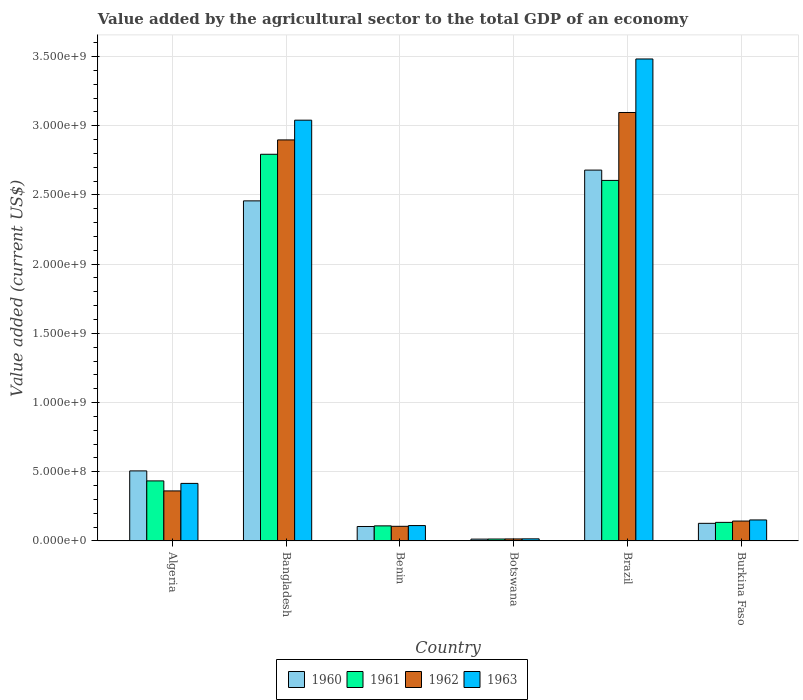Are the number of bars per tick equal to the number of legend labels?
Your answer should be compact. Yes. How many bars are there on the 3rd tick from the left?
Ensure brevity in your answer.  4. What is the label of the 4th group of bars from the left?
Keep it short and to the point. Botswana. In how many cases, is the number of bars for a given country not equal to the number of legend labels?
Offer a terse response. 0. What is the value added by the agricultural sector to the total GDP in 1963 in Brazil?
Keep it short and to the point. 3.48e+09. Across all countries, what is the maximum value added by the agricultural sector to the total GDP in 1963?
Give a very brief answer. 3.48e+09. Across all countries, what is the minimum value added by the agricultural sector to the total GDP in 1960?
Your answer should be compact. 1.31e+07. In which country was the value added by the agricultural sector to the total GDP in 1961 maximum?
Provide a succinct answer. Bangladesh. In which country was the value added by the agricultural sector to the total GDP in 1961 minimum?
Your answer should be very brief. Botswana. What is the total value added by the agricultural sector to the total GDP in 1961 in the graph?
Ensure brevity in your answer.  6.09e+09. What is the difference between the value added by the agricultural sector to the total GDP in 1962 in Botswana and that in Burkina Faso?
Ensure brevity in your answer.  -1.29e+08. What is the difference between the value added by the agricultural sector to the total GDP in 1961 in Burkina Faso and the value added by the agricultural sector to the total GDP in 1963 in Algeria?
Your response must be concise. -2.82e+08. What is the average value added by the agricultural sector to the total GDP in 1962 per country?
Make the answer very short. 1.10e+09. What is the difference between the value added by the agricultural sector to the total GDP of/in 1961 and value added by the agricultural sector to the total GDP of/in 1963 in Brazil?
Your answer should be very brief. -8.77e+08. In how many countries, is the value added by the agricultural sector to the total GDP in 1962 greater than 2800000000 US$?
Keep it short and to the point. 2. What is the ratio of the value added by the agricultural sector to the total GDP in 1961 in Botswana to that in Burkina Faso?
Your answer should be compact. 0.1. Is the value added by the agricultural sector to the total GDP in 1960 in Botswana less than that in Burkina Faso?
Provide a short and direct response. Yes. Is the difference between the value added by the agricultural sector to the total GDP in 1961 in Benin and Brazil greater than the difference between the value added by the agricultural sector to the total GDP in 1963 in Benin and Brazil?
Your response must be concise. Yes. What is the difference between the highest and the second highest value added by the agricultural sector to the total GDP in 1963?
Your answer should be very brief. 2.62e+09. What is the difference between the highest and the lowest value added by the agricultural sector to the total GDP in 1962?
Offer a terse response. 3.08e+09. What is the difference between two consecutive major ticks on the Y-axis?
Offer a terse response. 5.00e+08. How are the legend labels stacked?
Your answer should be compact. Horizontal. What is the title of the graph?
Offer a terse response. Value added by the agricultural sector to the total GDP of an economy. What is the label or title of the X-axis?
Provide a succinct answer. Country. What is the label or title of the Y-axis?
Your answer should be compact. Value added (current US$). What is the Value added (current US$) in 1960 in Algeria?
Keep it short and to the point. 5.06e+08. What is the Value added (current US$) of 1961 in Algeria?
Give a very brief answer. 4.34e+08. What is the Value added (current US$) in 1962 in Algeria?
Offer a terse response. 3.61e+08. What is the Value added (current US$) of 1963 in Algeria?
Provide a succinct answer. 4.16e+08. What is the Value added (current US$) of 1960 in Bangladesh?
Provide a succinct answer. 2.46e+09. What is the Value added (current US$) in 1961 in Bangladesh?
Give a very brief answer. 2.79e+09. What is the Value added (current US$) in 1962 in Bangladesh?
Provide a short and direct response. 2.90e+09. What is the Value added (current US$) of 1963 in Bangladesh?
Give a very brief answer. 3.04e+09. What is the Value added (current US$) of 1960 in Benin?
Provide a short and direct response. 1.04e+08. What is the Value added (current US$) in 1961 in Benin?
Offer a terse response. 1.09e+08. What is the Value added (current US$) in 1962 in Benin?
Your response must be concise. 1.06e+08. What is the Value added (current US$) in 1963 in Benin?
Offer a very short reply. 1.11e+08. What is the Value added (current US$) of 1960 in Botswana?
Give a very brief answer. 1.31e+07. What is the Value added (current US$) in 1961 in Botswana?
Your response must be concise. 1.38e+07. What is the Value added (current US$) of 1962 in Botswana?
Your response must be concise. 1.45e+07. What is the Value added (current US$) of 1963 in Botswana?
Your answer should be compact. 1.51e+07. What is the Value added (current US$) of 1960 in Brazil?
Make the answer very short. 2.68e+09. What is the Value added (current US$) in 1961 in Brazil?
Your response must be concise. 2.60e+09. What is the Value added (current US$) in 1962 in Brazil?
Offer a very short reply. 3.10e+09. What is the Value added (current US$) of 1963 in Brazil?
Ensure brevity in your answer.  3.48e+09. What is the Value added (current US$) of 1960 in Burkina Faso?
Give a very brief answer. 1.27e+08. What is the Value added (current US$) in 1961 in Burkina Faso?
Give a very brief answer. 1.34e+08. What is the Value added (current US$) in 1962 in Burkina Faso?
Your response must be concise. 1.44e+08. What is the Value added (current US$) of 1963 in Burkina Faso?
Your answer should be very brief. 1.52e+08. Across all countries, what is the maximum Value added (current US$) of 1960?
Ensure brevity in your answer.  2.68e+09. Across all countries, what is the maximum Value added (current US$) in 1961?
Make the answer very short. 2.79e+09. Across all countries, what is the maximum Value added (current US$) in 1962?
Your response must be concise. 3.10e+09. Across all countries, what is the maximum Value added (current US$) of 1963?
Your answer should be very brief. 3.48e+09. Across all countries, what is the minimum Value added (current US$) in 1960?
Offer a very short reply. 1.31e+07. Across all countries, what is the minimum Value added (current US$) of 1961?
Ensure brevity in your answer.  1.38e+07. Across all countries, what is the minimum Value added (current US$) of 1962?
Your response must be concise. 1.45e+07. Across all countries, what is the minimum Value added (current US$) in 1963?
Provide a succinct answer. 1.51e+07. What is the total Value added (current US$) of 1960 in the graph?
Offer a very short reply. 5.89e+09. What is the total Value added (current US$) in 1961 in the graph?
Your response must be concise. 6.09e+09. What is the total Value added (current US$) in 1962 in the graph?
Provide a succinct answer. 6.62e+09. What is the total Value added (current US$) in 1963 in the graph?
Offer a terse response. 7.22e+09. What is the difference between the Value added (current US$) of 1960 in Algeria and that in Bangladesh?
Keep it short and to the point. -1.95e+09. What is the difference between the Value added (current US$) in 1961 in Algeria and that in Bangladesh?
Ensure brevity in your answer.  -2.36e+09. What is the difference between the Value added (current US$) in 1962 in Algeria and that in Bangladesh?
Offer a very short reply. -2.54e+09. What is the difference between the Value added (current US$) of 1963 in Algeria and that in Bangladesh?
Your answer should be very brief. -2.62e+09. What is the difference between the Value added (current US$) in 1960 in Algeria and that in Benin?
Provide a succinct answer. 4.02e+08. What is the difference between the Value added (current US$) of 1961 in Algeria and that in Benin?
Keep it short and to the point. 3.25e+08. What is the difference between the Value added (current US$) of 1962 in Algeria and that in Benin?
Keep it short and to the point. 2.56e+08. What is the difference between the Value added (current US$) of 1963 in Algeria and that in Benin?
Make the answer very short. 3.05e+08. What is the difference between the Value added (current US$) in 1960 in Algeria and that in Botswana?
Your answer should be compact. 4.93e+08. What is the difference between the Value added (current US$) of 1961 in Algeria and that in Botswana?
Give a very brief answer. 4.20e+08. What is the difference between the Value added (current US$) of 1962 in Algeria and that in Botswana?
Keep it short and to the point. 3.47e+08. What is the difference between the Value added (current US$) in 1963 in Algeria and that in Botswana?
Provide a succinct answer. 4.01e+08. What is the difference between the Value added (current US$) in 1960 in Algeria and that in Brazil?
Offer a very short reply. -2.17e+09. What is the difference between the Value added (current US$) in 1961 in Algeria and that in Brazil?
Your response must be concise. -2.17e+09. What is the difference between the Value added (current US$) of 1962 in Algeria and that in Brazil?
Give a very brief answer. -2.73e+09. What is the difference between the Value added (current US$) in 1963 in Algeria and that in Brazil?
Offer a very short reply. -3.07e+09. What is the difference between the Value added (current US$) in 1960 in Algeria and that in Burkina Faso?
Your answer should be very brief. 3.79e+08. What is the difference between the Value added (current US$) in 1961 in Algeria and that in Burkina Faso?
Provide a short and direct response. 3.00e+08. What is the difference between the Value added (current US$) in 1962 in Algeria and that in Burkina Faso?
Make the answer very short. 2.18e+08. What is the difference between the Value added (current US$) in 1963 in Algeria and that in Burkina Faso?
Your answer should be very brief. 2.64e+08. What is the difference between the Value added (current US$) in 1960 in Bangladesh and that in Benin?
Your answer should be compact. 2.35e+09. What is the difference between the Value added (current US$) in 1961 in Bangladesh and that in Benin?
Offer a very short reply. 2.68e+09. What is the difference between the Value added (current US$) in 1962 in Bangladesh and that in Benin?
Give a very brief answer. 2.79e+09. What is the difference between the Value added (current US$) in 1963 in Bangladesh and that in Benin?
Offer a very short reply. 2.93e+09. What is the difference between the Value added (current US$) of 1960 in Bangladesh and that in Botswana?
Keep it short and to the point. 2.44e+09. What is the difference between the Value added (current US$) of 1961 in Bangladesh and that in Botswana?
Give a very brief answer. 2.78e+09. What is the difference between the Value added (current US$) in 1962 in Bangladesh and that in Botswana?
Provide a short and direct response. 2.88e+09. What is the difference between the Value added (current US$) in 1963 in Bangladesh and that in Botswana?
Your answer should be very brief. 3.02e+09. What is the difference between the Value added (current US$) of 1960 in Bangladesh and that in Brazil?
Your answer should be very brief. -2.22e+08. What is the difference between the Value added (current US$) in 1961 in Bangladesh and that in Brazil?
Make the answer very short. 1.89e+08. What is the difference between the Value added (current US$) of 1962 in Bangladesh and that in Brazil?
Your answer should be very brief. -1.98e+08. What is the difference between the Value added (current US$) in 1963 in Bangladesh and that in Brazil?
Keep it short and to the point. -4.42e+08. What is the difference between the Value added (current US$) of 1960 in Bangladesh and that in Burkina Faso?
Your answer should be very brief. 2.33e+09. What is the difference between the Value added (current US$) of 1961 in Bangladesh and that in Burkina Faso?
Keep it short and to the point. 2.66e+09. What is the difference between the Value added (current US$) of 1962 in Bangladesh and that in Burkina Faso?
Ensure brevity in your answer.  2.75e+09. What is the difference between the Value added (current US$) in 1963 in Bangladesh and that in Burkina Faso?
Offer a very short reply. 2.89e+09. What is the difference between the Value added (current US$) of 1960 in Benin and that in Botswana?
Offer a terse response. 9.13e+07. What is the difference between the Value added (current US$) in 1961 in Benin and that in Botswana?
Give a very brief answer. 9.51e+07. What is the difference between the Value added (current US$) of 1962 in Benin and that in Botswana?
Give a very brief answer. 9.12e+07. What is the difference between the Value added (current US$) in 1963 in Benin and that in Botswana?
Keep it short and to the point. 9.59e+07. What is the difference between the Value added (current US$) of 1960 in Benin and that in Brazil?
Ensure brevity in your answer.  -2.57e+09. What is the difference between the Value added (current US$) in 1961 in Benin and that in Brazil?
Your answer should be compact. -2.50e+09. What is the difference between the Value added (current US$) of 1962 in Benin and that in Brazil?
Keep it short and to the point. -2.99e+09. What is the difference between the Value added (current US$) in 1963 in Benin and that in Brazil?
Keep it short and to the point. -3.37e+09. What is the difference between the Value added (current US$) in 1960 in Benin and that in Burkina Faso?
Provide a succinct answer. -2.28e+07. What is the difference between the Value added (current US$) in 1961 in Benin and that in Burkina Faso?
Your response must be concise. -2.53e+07. What is the difference between the Value added (current US$) of 1962 in Benin and that in Burkina Faso?
Offer a very short reply. -3.80e+07. What is the difference between the Value added (current US$) of 1963 in Benin and that in Burkina Faso?
Make the answer very short. -4.07e+07. What is the difference between the Value added (current US$) of 1960 in Botswana and that in Brazil?
Ensure brevity in your answer.  -2.67e+09. What is the difference between the Value added (current US$) in 1961 in Botswana and that in Brazil?
Provide a succinct answer. -2.59e+09. What is the difference between the Value added (current US$) of 1962 in Botswana and that in Brazil?
Make the answer very short. -3.08e+09. What is the difference between the Value added (current US$) of 1963 in Botswana and that in Brazil?
Provide a short and direct response. -3.47e+09. What is the difference between the Value added (current US$) of 1960 in Botswana and that in Burkina Faso?
Your answer should be compact. -1.14e+08. What is the difference between the Value added (current US$) in 1961 in Botswana and that in Burkina Faso?
Provide a succinct answer. -1.20e+08. What is the difference between the Value added (current US$) of 1962 in Botswana and that in Burkina Faso?
Make the answer very short. -1.29e+08. What is the difference between the Value added (current US$) in 1963 in Botswana and that in Burkina Faso?
Ensure brevity in your answer.  -1.37e+08. What is the difference between the Value added (current US$) in 1960 in Brazil and that in Burkina Faso?
Your answer should be compact. 2.55e+09. What is the difference between the Value added (current US$) of 1961 in Brazil and that in Burkina Faso?
Keep it short and to the point. 2.47e+09. What is the difference between the Value added (current US$) of 1962 in Brazil and that in Burkina Faso?
Make the answer very short. 2.95e+09. What is the difference between the Value added (current US$) in 1963 in Brazil and that in Burkina Faso?
Ensure brevity in your answer.  3.33e+09. What is the difference between the Value added (current US$) in 1960 in Algeria and the Value added (current US$) in 1961 in Bangladesh?
Make the answer very short. -2.29e+09. What is the difference between the Value added (current US$) of 1960 in Algeria and the Value added (current US$) of 1962 in Bangladesh?
Provide a short and direct response. -2.39e+09. What is the difference between the Value added (current US$) in 1960 in Algeria and the Value added (current US$) in 1963 in Bangladesh?
Your response must be concise. -2.53e+09. What is the difference between the Value added (current US$) of 1961 in Algeria and the Value added (current US$) of 1962 in Bangladesh?
Ensure brevity in your answer.  -2.46e+09. What is the difference between the Value added (current US$) of 1961 in Algeria and the Value added (current US$) of 1963 in Bangladesh?
Give a very brief answer. -2.61e+09. What is the difference between the Value added (current US$) in 1962 in Algeria and the Value added (current US$) in 1963 in Bangladesh?
Make the answer very short. -2.68e+09. What is the difference between the Value added (current US$) of 1960 in Algeria and the Value added (current US$) of 1961 in Benin?
Your answer should be very brief. 3.97e+08. What is the difference between the Value added (current US$) of 1960 in Algeria and the Value added (current US$) of 1962 in Benin?
Make the answer very short. 4.00e+08. What is the difference between the Value added (current US$) of 1960 in Algeria and the Value added (current US$) of 1963 in Benin?
Your answer should be compact. 3.95e+08. What is the difference between the Value added (current US$) of 1961 in Algeria and the Value added (current US$) of 1962 in Benin?
Give a very brief answer. 3.28e+08. What is the difference between the Value added (current US$) of 1961 in Algeria and the Value added (current US$) of 1963 in Benin?
Provide a succinct answer. 3.23e+08. What is the difference between the Value added (current US$) in 1962 in Algeria and the Value added (current US$) in 1963 in Benin?
Your response must be concise. 2.50e+08. What is the difference between the Value added (current US$) in 1960 in Algeria and the Value added (current US$) in 1961 in Botswana?
Make the answer very short. 4.92e+08. What is the difference between the Value added (current US$) of 1960 in Algeria and the Value added (current US$) of 1962 in Botswana?
Your response must be concise. 4.92e+08. What is the difference between the Value added (current US$) in 1960 in Algeria and the Value added (current US$) in 1963 in Botswana?
Your answer should be very brief. 4.91e+08. What is the difference between the Value added (current US$) in 1961 in Algeria and the Value added (current US$) in 1962 in Botswana?
Your response must be concise. 4.19e+08. What is the difference between the Value added (current US$) in 1961 in Algeria and the Value added (current US$) in 1963 in Botswana?
Offer a very short reply. 4.19e+08. What is the difference between the Value added (current US$) in 1962 in Algeria and the Value added (current US$) in 1963 in Botswana?
Make the answer very short. 3.46e+08. What is the difference between the Value added (current US$) in 1960 in Algeria and the Value added (current US$) in 1961 in Brazil?
Provide a succinct answer. -2.10e+09. What is the difference between the Value added (current US$) of 1960 in Algeria and the Value added (current US$) of 1962 in Brazil?
Offer a terse response. -2.59e+09. What is the difference between the Value added (current US$) of 1960 in Algeria and the Value added (current US$) of 1963 in Brazil?
Provide a succinct answer. -2.98e+09. What is the difference between the Value added (current US$) of 1961 in Algeria and the Value added (current US$) of 1962 in Brazil?
Ensure brevity in your answer.  -2.66e+09. What is the difference between the Value added (current US$) in 1961 in Algeria and the Value added (current US$) in 1963 in Brazil?
Your answer should be compact. -3.05e+09. What is the difference between the Value added (current US$) of 1962 in Algeria and the Value added (current US$) of 1963 in Brazil?
Make the answer very short. -3.12e+09. What is the difference between the Value added (current US$) in 1960 in Algeria and the Value added (current US$) in 1961 in Burkina Faso?
Your answer should be very brief. 3.72e+08. What is the difference between the Value added (current US$) of 1960 in Algeria and the Value added (current US$) of 1962 in Burkina Faso?
Offer a terse response. 3.62e+08. What is the difference between the Value added (current US$) in 1960 in Algeria and the Value added (current US$) in 1963 in Burkina Faso?
Provide a short and direct response. 3.54e+08. What is the difference between the Value added (current US$) in 1961 in Algeria and the Value added (current US$) in 1962 in Burkina Faso?
Give a very brief answer. 2.90e+08. What is the difference between the Value added (current US$) in 1961 in Algeria and the Value added (current US$) in 1963 in Burkina Faso?
Give a very brief answer. 2.82e+08. What is the difference between the Value added (current US$) of 1962 in Algeria and the Value added (current US$) of 1963 in Burkina Faso?
Offer a terse response. 2.10e+08. What is the difference between the Value added (current US$) in 1960 in Bangladesh and the Value added (current US$) in 1961 in Benin?
Keep it short and to the point. 2.35e+09. What is the difference between the Value added (current US$) in 1960 in Bangladesh and the Value added (current US$) in 1962 in Benin?
Your answer should be compact. 2.35e+09. What is the difference between the Value added (current US$) of 1960 in Bangladesh and the Value added (current US$) of 1963 in Benin?
Ensure brevity in your answer.  2.35e+09. What is the difference between the Value added (current US$) of 1961 in Bangladesh and the Value added (current US$) of 1962 in Benin?
Provide a succinct answer. 2.69e+09. What is the difference between the Value added (current US$) in 1961 in Bangladesh and the Value added (current US$) in 1963 in Benin?
Keep it short and to the point. 2.68e+09. What is the difference between the Value added (current US$) in 1962 in Bangladesh and the Value added (current US$) in 1963 in Benin?
Offer a terse response. 2.79e+09. What is the difference between the Value added (current US$) in 1960 in Bangladesh and the Value added (current US$) in 1961 in Botswana?
Provide a succinct answer. 2.44e+09. What is the difference between the Value added (current US$) in 1960 in Bangladesh and the Value added (current US$) in 1962 in Botswana?
Your response must be concise. 2.44e+09. What is the difference between the Value added (current US$) of 1960 in Bangladesh and the Value added (current US$) of 1963 in Botswana?
Your answer should be very brief. 2.44e+09. What is the difference between the Value added (current US$) in 1961 in Bangladesh and the Value added (current US$) in 1962 in Botswana?
Keep it short and to the point. 2.78e+09. What is the difference between the Value added (current US$) in 1961 in Bangladesh and the Value added (current US$) in 1963 in Botswana?
Offer a terse response. 2.78e+09. What is the difference between the Value added (current US$) of 1962 in Bangladesh and the Value added (current US$) of 1963 in Botswana?
Offer a very short reply. 2.88e+09. What is the difference between the Value added (current US$) of 1960 in Bangladesh and the Value added (current US$) of 1961 in Brazil?
Provide a short and direct response. -1.48e+08. What is the difference between the Value added (current US$) in 1960 in Bangladesh and the Value added (current US$) in 1962 in Brazil?
Your response must be concise. -6.39e+08. What is the difference between the Value added (current US$) in 1960 in Bangladesh and the Value added (current US$) in 1963 in Brazil?
Offer a very short reply. -1.03e+09. What is the difference between the Value added (current US$) of 1961 in Bangladesh and the Value added (current US$) of 1962 in Brazil?
Your answer should be very brief. -3.02e+08. What is the difference between the Value added (current US$) in 1961 in Bangladesh and the Value added (current US$) in 1963 in Brazil?
Offer a very short reply. -6.89e+08. What is the difference between the Value added (current US$) of 1962 in Bangladesh and the Value added (current US$) of 1963 in Brazil?
Ensure brevity in your answer.  -5.85e+08. What is the difference between the Value added (current US$) of 1960 in Bangladesh and the Value added (current US$) of 1961 in Burkina Faso?
Make the answer very short. 2.32e+09. What is the difference between the Value added (current US$) of 1960 in Bangladesh and the Value added (current US$) of 1962 in Burkina Faso?
Keep it short and to the point. 2.31e+09. What is the difference between the Value added (current US$) of 1960 in Bangladesh and the Value added (current US$) of 1963 in Burkina Faso?
Provide a short and direct response. 2.31e+09. What is the difference between the Value added (current US$) in 1961 in Bangladesh and the Value added (current US$) in 1962 in Burkina Faso?
Keep it short and to the point. 2.65e+09. What is the difference between the Value added (current US$) in 1961 in Bangladesh and the Value added (current US$) in 1963 in Burkina Faso?
Provide a succinct answer. 2.64e+09. What is the difference between the Value added (current US$) of 1962 in Bangladesh and the Value added (current US$) of 1963 in Burkina Faso?
Provide a short and direct response. 2.75e+09. What is the difference between the Value added (current US$) in 1960 in Benin and the Value added (current US$) in 1961 in Botswana?
Keep it short and to the point. 9.06e+07. What is the difference between the Value added (current US$) of 1960 in Benin and the Value added (current US$) of 1962 in Botswana?
Your answer should be very brief. 8.99e+07. What is the difference between the Value added (current US$) in 1960 in Benin and the Value added (current US$) in 1963 in Botswana?
Offer a very short reply. 8.93e+07. What is the difference between the Value added (current US$) in 1961 in Benin and the Value added (current US$) in 1962 in Botswana?
Your answer should be compact. 9.44e+07. What is the difference between the Value added (current US$) in 1961 in Benin and the Value added (current US$) in 1963 in Botswana?
Offer a very short reply. 9.37e+07. What is the difference between the Value added (current US$) in 1962 in Benin and the Value added (current US$) in 1963 in Botswana?
Your response must be concise. 9.06e+07. What is the difference between the Value added (current US$) of 1960 in Benin and the Value added (current US$) of 1961 in Brazil?
Keep it short and to the point. -2.50e+09. What is the difference between the Value added (current US$) of 1960 in Benin and the Value added (current US$) of 1962 in Brazil?
Make the answer very short. -2.99e+09. What is the difference between the Value added (current US$) in 1960 in Benin and the Value added (current US$) in 1963 in Brazil?
Ensure brevity in your answer.  -3.38e+09. What is the difference between the Value added (current US$) in 1961 in Benin and the Value added (current US$) in 1962 in Brazil?
Your answer should be very brief. -2.99e+09. What is the difference between the Value added (current US$) in 1961 in Benin and the Value added (current US$) in 1963 in Brazil?
Give a very brief answer. -3.37e+09. What is the difference between the Value added (current US$) of 1962 in Benin and the Value added (current US$) of 1963 in Brazil?
Ensure brevity in your answer.  -3.38e+09. What is the difference between the Value added (current US$) of 1960 in Benin and the Value added (current US$) of 1961 in Burkina Faso?
Ensure brevity in your answer.  -2.98e+07. What is the difference between the Value added (current US$) in 1960 in Benin and the Value added (current US$) in 1962 in Burkina Faso?
Provide a short and direct response. -3.93e+07. What is the difference between the Value added (current US$) in 1960 in Benin and the Value added (current US$) in 1963 in Burkina Faso?
Your answer should be compact. -4.73e+07. What is the difference between the Value added (current US$) in 1961 in Benin and the Value added (current US$) in 1962 in Burkina Faso?
Offer a terse response. -3.48e+07. What is the difference between the Value added (current US$) in 1961 in Benin and the Value added (current US$) in 1963 in Burkina Faso?
Keep it short and to the point. -4.28e+07. What is the difference between the Value added (current US$) in 1962 in Benin and the Value added (current US$) in 1963 in Burkina Faso?
Your response must be concise. -4.60e+07. What is the difference between the Value added (current US$) of 1960 in Botswana and the Value added (current US$) of 1961 in Brazil?
Your answer should be very brief. -2.59e+09. What is the difference between the Value added (current US$) in 1960 in Botswana and the Value added (current US$) in 1962 in Brazil?
Offer a very short reply. -3.08e+09. What is the difference between the Value added (current US$) in 1960 in Botswana and the Value added (current US$) in 1963 in Brazil?
Make the answer very short. -3.47e+09. What is the difference between the Value added (current US$) of 1961 in Botswana and the Value added (current US$) of 1962 in Brazil?
Provide a succinct answer. -3.08e+09. What is the difference between the Value added (current US$) in 1961 in Botswana and the Value added (current US$) in 1963 in Brazil?
Your response must be concise. -3.47e+09. What is the difference between the Value added (current US$) of 1962 in Botswana and the Value added (current US$) of 1963 in Brazil?
Ensure brevity in your answer.  -3.47e+09. What is the difference between the Value added (current US$) of 1960 in Botswana and the Value added (current US$) of 1961 in Burkina Faso?
Provide a succinct answer. -1.21e+08. What is the difference between the Value added (current US$) of 1960 in Botswana and the Value added (current US$) of 1962 in Burkina Faso?
Give a very brief answer. -1.31e+08. What is the difference between the Value added (current US$) in 1960 in Botswana and the Value added (current US$) in 1963 in Burkina Faso?
Provide a short and direct response. -1.39e+08. What is the difference between the Value added (current US$) in 1961 in Botswana and the Value added (current US$) in 1962 in Burkina Faso?
Your answer should be very brief. -1.30e+08. What is the difference between the Value added (current US$) of 1961 in Botswana and the Value added (current US$) of 1963 in Burkina Faso?
Your answer should be compact. -1.38e+08. What is the difference between the Value added (current US$) in 1962 in Botswana and the Value added (current US$) in 1963 in Burkina Faso?
Give a very brief answer. -1.37e+08. What is the difference between the Value added (current US$) of 1960 in Brazil and the Value added (current US$) of 1961 in Burkina Faso?
Your answer should be compact. 2.55e+09. What is the difference between the Value added (current US$) of 1960 in Brazil and the Value added (current US$) of 1962 in Burkina Faso?
Your answer should be compact. 2.54e+09. What is the difference between the Value added (current US$) of 1960 in Brazil and the Value added (current US$) of 1963 in Burkina Faso?
Your answer should be very brief. 2.53e+09. What is the difference between the Value added (current US$) in 1961 in Brazil and the Value added (current US$) in 1962 in Burkina Faso?
Keep it short and to the point. 2.46e+09. What is the difference between the Value added (current US$) in 1961 in Brazil and the Value added (current US$) in 1963 in Burkina Faso?
Your answer should be very brief. 2.45e+09. What is the difference between the Value added (current US$) of 1962 in Brazil and the Value added (current US$) of 1963 in Burkina Faso?
Keep it short and to the point. 2.94e+09. What is the average Value added (current US$) of 1960 per country?
Your response must be concise. 9.81e+08. What is the average Value added (current US$) of 1961 per country?
Keep it short and to the point. 1.01e+09. What is the average Value added (current US$) in 1962 per country?
Offer a terse response. 1.10e+09. What is the average Value added (current US$) in 1963 per country?
Make the answer very short. 1.20e+09. What is the difference between the Value added (current US$) in 1960 and Value added (current US$) in 1961 in Algeria?
Ensure brevity in your answer.  7.23e+07. What is the difference between the Value added (current US$) in 1960 and Value added (current US$) in 1962 in Algeria?
Your answer should be very brief. 1.45e+08. What is the difference between the Value added (current US$) in 1960 and Value added (current US$) in 1963 in Algeria?
Keep it short and to the point. 9.04e+07. What is the difference between the Value added (current US$) in 1961 and Value added (current US$) in 1962 in Algeria?
Make the answer very short. 7.23e+07. What is the difference between the Value added (current US$) of 1961 and Value added (current US$) of 1963 in Algeria?
Your answer should be compact. 1.81e+07. What is the difference between the Value added (current US$) in 1962 and Value added (current US$) in 1963 in Algeria?
Offer a terse response. -5.42e+07. What is the difference between the Value added (current US$) of 1960 and Value added (current US$) of 1961 in Bangladesh?
Keep it short and to the point. -3.37e+08. What is the difference between the Value added (current US$) of 1960 and Value added (current US$) of 1962 in Bangladesh?
Provide a short and direct response. -4.40e+08. What is the difference between the Value added (current US$) in 1960 and Value added (current US$) in 1963 in Bangladesh?
Your answer should be very brief. -5.83e+08. What is the difference between the Value added (current US$) in 1961 and Value added (current US$) in 1962 in Bangladesh?
Offer a terse response. -1.04e+08. What is the difference between the Value added (current US$) in 1961 and Value added (current US$) in 1963 in Bangladesh?
Offer a terse response. -2.46e+08. What is the difference between the Value added (current US$) of 1962 and Value added (current US$) of 1963 in Bangladesh?
Give a very brief answer. -1.43e+08. What is the difference between the Value added (current US$) in 1960 and Value added (current US$) in 1961 in Benin?
Your answer should be very brief. -4.46e+06. What is the difference between the Value added (current US$) of 1960 and Value added (current US$) of 1962 in Benin?
Give a very brief answer. -1.30e+06. What is the difference between the Value added (current US$) in 1960 and Value added (current US$) in 1963 in Benin?
Your response must be concise. -6.61e+06. What is the difference between the Value added (current US$) in 1961 and Value added (current US$) in 1962 in Benin?
Make the answer very short. 3.16e+06. What is the difference between the Value added (current US$) of 1961 and Value added (current US$) of 1963 in Benin?
Provide a succinct answer. -2.15e+06. What is the difference between the Value added (current US$) in 1962 and Value added (current US$) in 1963 in Benin?
Make the answer very short. -5.30e+06. What is the difference between the Value added (current US$) in 1960 and Value added (current US$) in 1961 in Botswana?
Give a very brief answer. -6.50e+05. What is the difference between the Value added (current US$) in 1960 and Value added (current US$) in 1962 in Botswana?
Give a very brief answer. -1.35e+06. What is the difference between the Value added (current US$) in 1960 and Value added (current US$) in 1963 in Botswana?
Keep it short and to the point. -1.99e+06. What is the difference between the Value added (current US$) of 1961 and Value added (current US$) of 1962 in Botswana?
Keep it short and to the point. -7.04e+05. What is the difference between the Value added (current US$) of 1961 and Value added (current US$) of 1963 in Botswana?
Provide a succinct answer. -1.34e+06. What is the difference between the Value added (current US$) of 1962 and Value added (current US$) of 1963 in Botswana?
Give a very brief answer. -6.34e+05. What is the difference between the Value added (current US$) in 1960 and Value added (current US$) in 1961 in Brazil?
Your response must be concise. 7.45e+07. What is the difference between the Value added (current US$) in 1960 and Value added (current US$) in 1962 in Brazil?
Your response must be concise. -4.16e+08. What is the difference between the Value added (current US$) of 1960 and Value added (current US$) of 1963 in Brazil?
Ensure brevity in your answer.  -8.03e+08. What is the difference between the Value added (current US$) in 1961 and Value added (current US$) in 1962 in Brazil?
Provide a succinct answer. -4.91e+08. What is the difference between the Value added (current US$) of 1961 and Value added (current US$) of 1963 in Brazil?
Your answer should be compact. -8.77e+08. What is the difference between the Value added (current US$) in 1962 and Value added (current US$) in 1963 in Brazil?
Your response must be concise. -3.87e+08. What is the difference between the Value added (current US$) in 1960 and Value added (current US$) in 1961 in Burkina Faso?
Your response must be concise. -7.00e+06. What is the difference between the Value added (current US$) of 1960 and Value added (current US$) of 1962 in Burkina Faso?
Your answer should be compact. -1.65e+07. What is the difference between the Value added (current US$) in 1960 and Value added (current US$) in 1963 in Burkina Faso?
Your answer should be compact. -2.45e+07. What is the difference between the Value added (current US$) in 1961 and Value added (current US$) in 1962 in Burkina Faso?
Offer a terse response. -9.53e+06. What is the difference between the Value added (current US$) in 1961 and Value added (current US$) in 1963 in Burkina Faso?
Your answer should be very brief. -1.75e+07. What is the difference between the Value added (current US$) of 1962 and Value added (current US$) of 1963 in Burkina Faso?
Keep it short and to the point. -7.98e+06. What is the ratio of the Value added (current US$) of 1960 in Algeria to that in Bangladesh?
Your answer should be compact. 0.21. What is the ratio of the Value added (current US$) in 1961 in Algeria to that in Bangladesh?
Your answer should be very brief. 0.16. What is the ratio of the Value added (current US$) in 1962 in Algeria to that in Bangladesh?
Give a very brief answer. 0.12. What is the ratio of the Value added (current US$) in 1963 in Algeria to that in Bangladesh?
Your response must be concise. 0.14. What is the ratio of the Value added (current US$) of 1960 in Algeria to that in Benin?
Keep it short and to the point. 4.85. What is the ratio of the Value added (current US$) of 1961 in Algeria to that in Benin?
Offer a terse response. 3.98. What is the ratio of the Value added (current US$) of 1962 in Algeria to that in Benin?
Ensure brevity in your answer.  3.42. What is the ratio of the Value added (current US$) of 1963 in Algeria to that in Benin?
Ensure brevity in your answer.  3.74. What is the ratio of the Value added (current US$) in 1960 in Algeria to that in Botswana?
Offer a very short reply. 38.5. What is the ratio of the Value added (current US$) of 1961 in Algeria to that in Botswana?
Make the answer very short. 31.45. What is the ratio of the Value added (current US$) of 1962 in Algeria to that in Botswana?
Your answer should be compact. 24.93. What is the ratio of the Value added (current US$) in 1963 in Algeria to that in Botswana?
Provide a succinct answer. 27.47. What is the ratio of the Value added (current US$) of 1960 in Algeria to that in Brazil?
Make the answer very short. 0.19. What is the ratio of the Value added (current US$) in 1961 in Algeria to that in Brazil?
Make the answer very short. 0.17. What is the ratio of the Value added (current US$) in 1962 in Algeria to that in Brazil?
Your answer should be compact. 0.12. What is the ratio of the Value added (current US$) in 1963 in Algeria to that in Brazil?
Your answer should be compact. 0.12. What is the ratio of the Value added (current US$) in 1960 in Algeria to that in Burkina Faso?
Offer a very short reply. 3.98. What is the ratio of the Value added (current US$) of 1961 in Algeria to that in Burkina Faso?
Ensure brevity in your answer.  3.23. What is the ratio of the Value added (current US$) in 1962 in Algeria to that in Burkina Faso?
Offer a terse response. 2.52. What is the ratio of the Value added (current US$) of 1963 in Algeria to that in Burkina Faso?
Ensure brevity in your answer.  2.74. What is the ratio of the Value added (current US$) of 1960 in Bangladesh to that in Benin?
Give a very brief answer. 23.53. What is the ratio of the Value added (current US$) in 1961 in Bangladesh to that in Benin?
Offer a very short reply. 25.66. What is the ratio of the Value added (current US$) of 1962 in Bangladesh to that in Benin?
Your answer should be compact. 27.41. What is the ratio of the Value added (current US$) in 1963 in Bangladesh to that in Benin?
Provide a succinct answer. 27.38. What is the ratio of the Value added (current US$) in 1960 in Bangladesh to that in Botswana?
Offer a very short reply. 186.92. What is the ratio of the Value added (current US$) in 1961 in Bangladesh to that in Botswana?
Ensure brevity in your answer.  202.51. What is the ratio of the Value added (current US$) in 1962 in Bangladesh to that in Botswana?
Give a very brief answer. 199.83. What is the ratio of the Value added (current US$) of 1963 in Bangladesh to that in Botswana?
Offer a terse response. 200.88. What is the ratio of the Value added (current US$) in 1960 in Bangladesh to that in Brazil?
Make the answer very short. 0.92. What is the ratio of the Value added (current US$) of 1961 in Bangladesh to that in Brazil?
Ensure brevity in your answer.  1.07. What is the ratio of the Value added (current US$) of 1962 in Bangladesh to that in Brazil?
Keep it short and to the point. 0.94. What is the ratio of the Value added (current US$) of 1963 in Bangladesh to that in Brazil?
Your answer should be very brief. 0.87. What is the ratio of the Value added (current US$) of 1960 in Bangladesh to that in Burkina Faso?
Your answer should be compact. 19.32. What is the ratio of the Value added (current US$) of 1961 in Bangladesh to that in Burkina Faso?
Provide a short and direct response. 20.82. What is the ratio of the Value added (current US$) in 1962 in Bangladesh to that in Burkina Faso?
Your answer should be very brief. 20.16. What is the ratio of the Value added (current US$) of 1963 in Bangladesh to that in Burkina Faso?
Provide a succinct answer. 20.04. What is the ratio of the Value added (current US$) of 1960 in Benin to that in Botswana?
Your response must be concise. 7.94. What is the ratio of the Value added (current US$) of 1961 in Benin to that in Botswana?
Ensure brevity in your answer.  7.89. What is the ratio of the Value added (current US$) of 1962 in Benin to that in Botswana?
Your response must be concise. 7.29. What is the ratio of the Value added (current US$) of 1963 in Benin to that in Botswana?
Offer a terse response. 7.34. What is the ratio of the Value added (current US$) of 1960 in Benin to that in Brazil?
Your answer should be very brief. 0.04. What is the ratio of the Value added (current US$) of 1961 in Benin to that in Brazil?
Ensure brevity in your answer.  0.04. What is the ratio of the Value added (current US$) in 1962 in Benin to that in Brazil?
Make the answer very short. 0.03. What is the ratio of the Value added (current US$) of 1963 in Benin to that in Brazil?
Keep it short and to the point. 0.03. What is the ratio of the Value added (current US$) of 1960 in Benin to that in Burkina Faso?
Your answer should be compact. 0.82. What is the ratio of the Value added (current US$) of 1961 in Benin to that in Burkina Faso?
Keep it short and to the point. 0.81. What is the ratio of the Value added (current US$) of 1962 in Benin to that in Burkina Faso?
Give a very brief answer. 0.74. What is the ratio of the Value added (current US$) in 1963 in Benin to that in Burkina Faso?
Make the answer very short. 0.73. What is the ratio of the Value added (current US$) in 1960 in Botswana to that in Brazil?
Give a very brief answer. 0. What is the ratio of the Value added (current US$) of 1961 in Botswana to that in Brazil?
Offer a very short reply. 0.01. What is the ratio of the Value added (current US$) in 1962 in Botswana to that in Brazil?
Ensure brevity in your answer.  0. What is the ratio of the Value added (current US$) of 1963 in Botswana to that in Brazil?
Ensure brevity in your answer.  0. What is the ratio of the Value added (current US$) of 1960 in Botswana to that in Burkina Faso?
Your answer should be compact. 0.1. What is the ratio of the Value added (current US$) in 1961 in Botswana to that in Burkina Faso?
Your answer should be compact. 0.1. What is the ratio of the Value added (current US$) in 1962 in Botswana to that in Burkina Faso?
Provide a short and direct response. 0.1. What is the ratio of the Value added (current US$) in 1963 in Botswana to that in Burkina Faso?
Keep it short and to the point. 0.1. What is the ratio of the Value added (current US$) in 1960 in Brazil to that in Burkina Faso?
Your response must be concise. 21.07. What is the ratio of the Value added (current US$) of 1961 in Brazil to that in Burkina Faso?
Your answer should be compact. 19.41. What is the ratio of the Value added (current US$) of 1962 in Brazil to that in Burkina Faso?
Give a very brief answer. 21.54. What is the ratio of the Value added (current US$) of 1963 in Brazil to that in Burkina Faso?
Keep it short and to the point. 22.96. What is the difference between the highest and the second highest Value added (current US$) in 1960?
Give a very brief answer. 2.22e+08. What is the difference between the highest and the second highest Value added (current US$) in 1961?
Offer a very short reply. 1.89e+08. What is the difference between the highest and the second highest Value added (current US$) of 1962?
Your answer should be very brief. 1.98e+08. What is the difference between the highest and the second highest Value added (current US$) in 1963?
Your answer should be compact. 4.42e+08. What is the difference between the highest and the lowest Value added (current US$) in 1960?
Keep it short and to the point. 2.67e+09. What is the difference between the highest and the lowest Value added (current US$) of 1961?
Keep it short and to the point. 2.78e+09. What is the difference between the highest and the lowest Value added (current US$) of 1962?
Your answer should be compact. 3.08e+09. What is the difference between the highest and the lowest Value added (current US$) in 1963?
Your answer should be compact. 3.47e+09. 